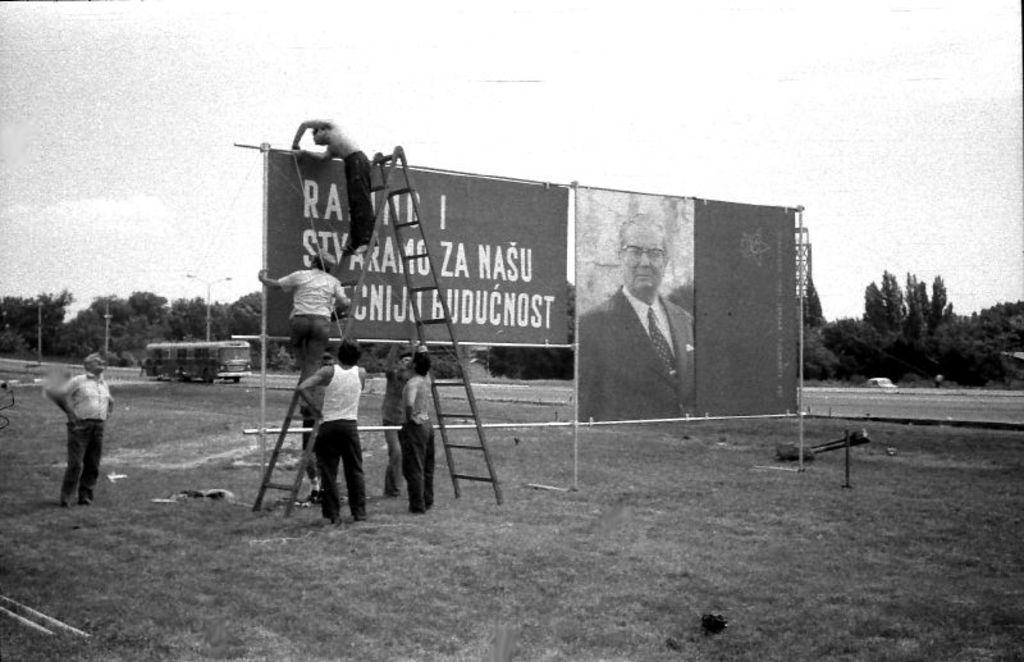How would you summarize this image in a sentence or two? It is a black and white picture. In the center of the image we can see a few people are standing. Among them, we can see two persons are standing on the ladder and they are holding some objects. And we can see one hoarding board. On the hoarding board, we can see one person. And we can see some text on the hoarding board. In the background we can see the sky, trees, grass, poles, vehicles and a few other objects. 